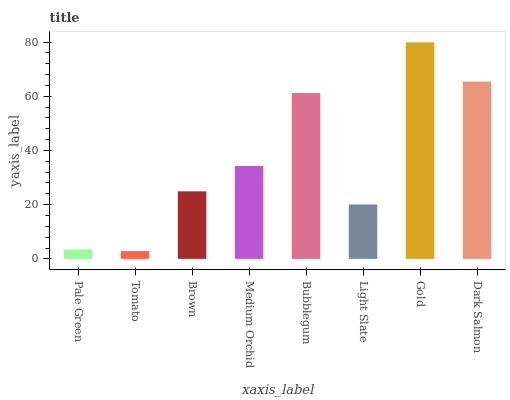Is Tomato the minimum?
Answer yes or no. Yes. Is Gold the maximum?
Answer yes or no. Yes. Is Brown the minimum?
Answer yes or no. No. Is Brown the maximum?
Answer yes or no. No. Is Brown greater than Tomato?
Answer yes or no. Yes. Is Tomato less than Brown?
Answer yes or no. Yes. Is Tomato greater than Brown?
Answer yes or no. No. Is Brown less than Tomato?
Answer yes or no. No. Is Medium Orchid the high median?
Answer yes or no. Yes. Is Brown the low median?
Answer yes or no. Yes. Is Light Slate the high median?
Answer yes or no. No. Is Gold the low median?
Answer yes or no. No. 